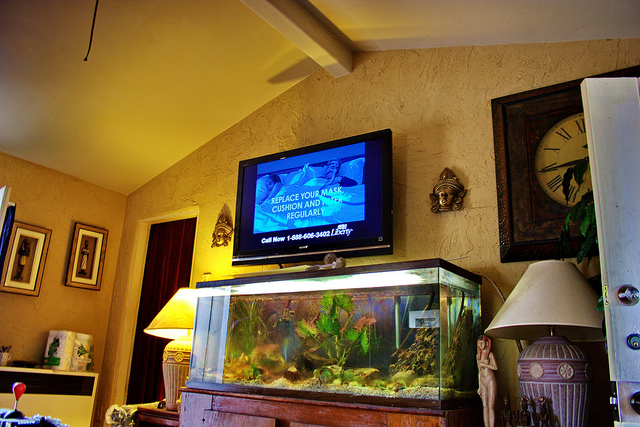Please transcribe the text in this image. MASK YOUR AND REPLACE CUSHION V XI 1-888-606-3402 Cal REGULARLY 